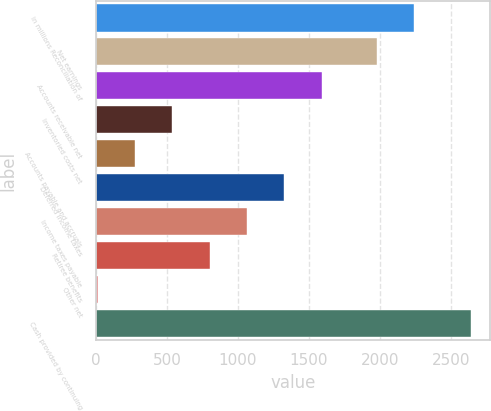<chart> <loc_0><loc_0><loc_500><loc_500><bar_chart><fcel>in millions Reconciliation of<fcel>Net earnings<fcel>Accounts receivable net<fcel>Inventoried costs net<fcel>Accounts payable and accruals<fcel>Deferred income taxes<fcel>Income taxes payable<fcel>Retiree benefits<fcel>Other net<fcel>Cash provided by continuing<nl><fcel>2240.8<fcel>1978<fcel>1588.8<fcel>537.6<fcel>274.8<fcel>1326<fcel>1063.2<fcel>800.4<fcel>12<fcel>2640<nl></chart> 